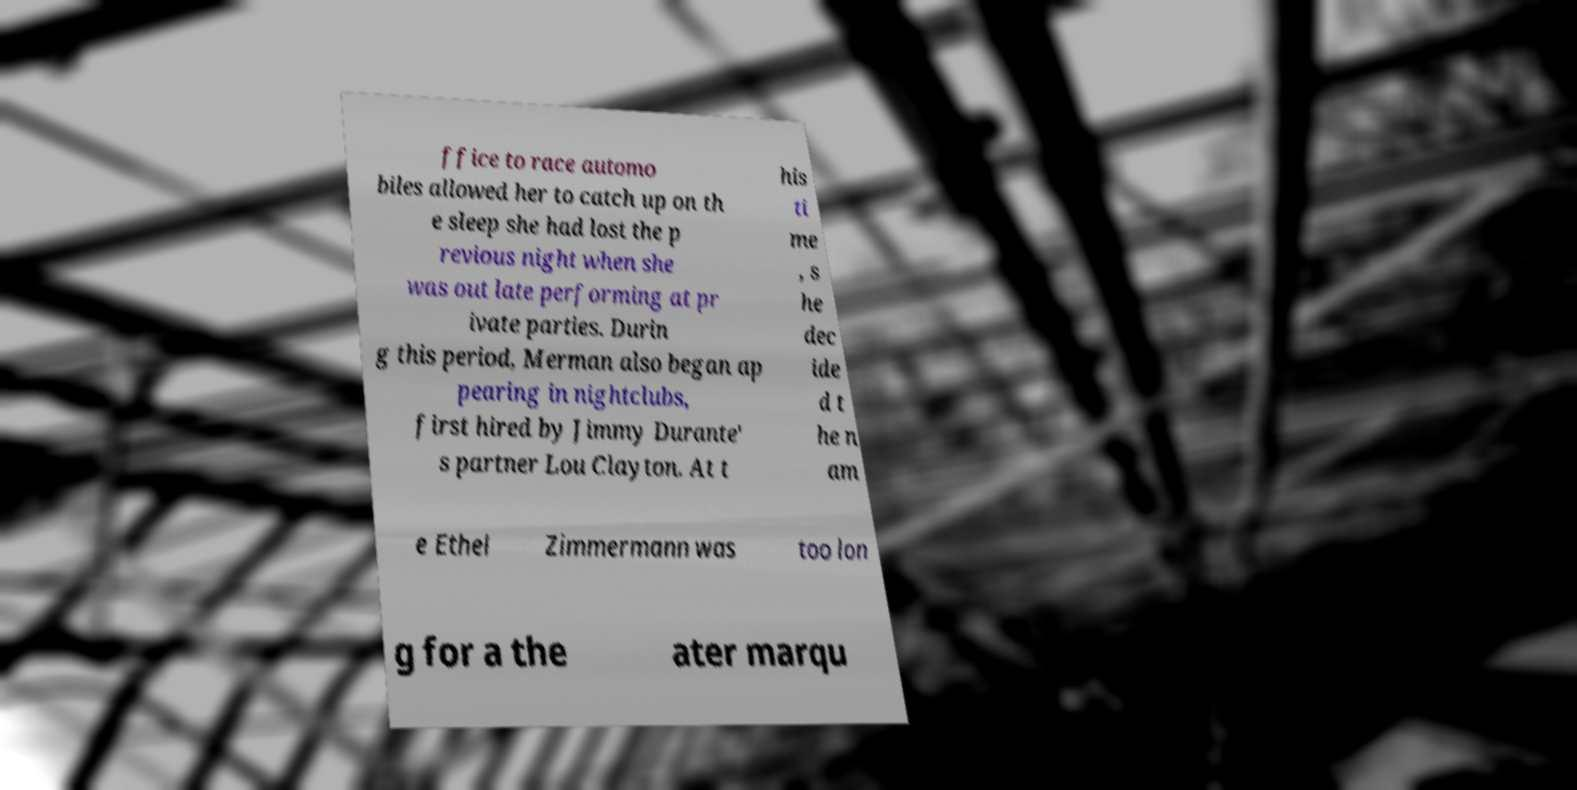Could you assist in decoding the text presented in this image and type it out clearly? ffice to race automo biles allowed her to catch up on th e sleep she had lost the p revious night when she was out late performing at pr ivate parties. Durin g this period, Merman also began ap pearing in nightclubs, first hired by Jimmy Durante' s partner Lou Clayton. At t his ti me , s he dec ide d t he n am e Ethel Zimmermann was too lon g for a the ater marqu 